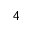Convert formula to latex. <formula><loc_0><loc_0><loc_500><loc_500>4</formula> 